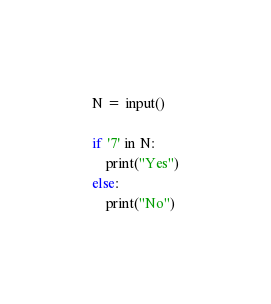Convert code to text. <code><loc_0><loc_0><loc_500><loc_500><_Python_>N = input()

if '7' in N:
    print("Yes")
else:
    print("No")</code> 